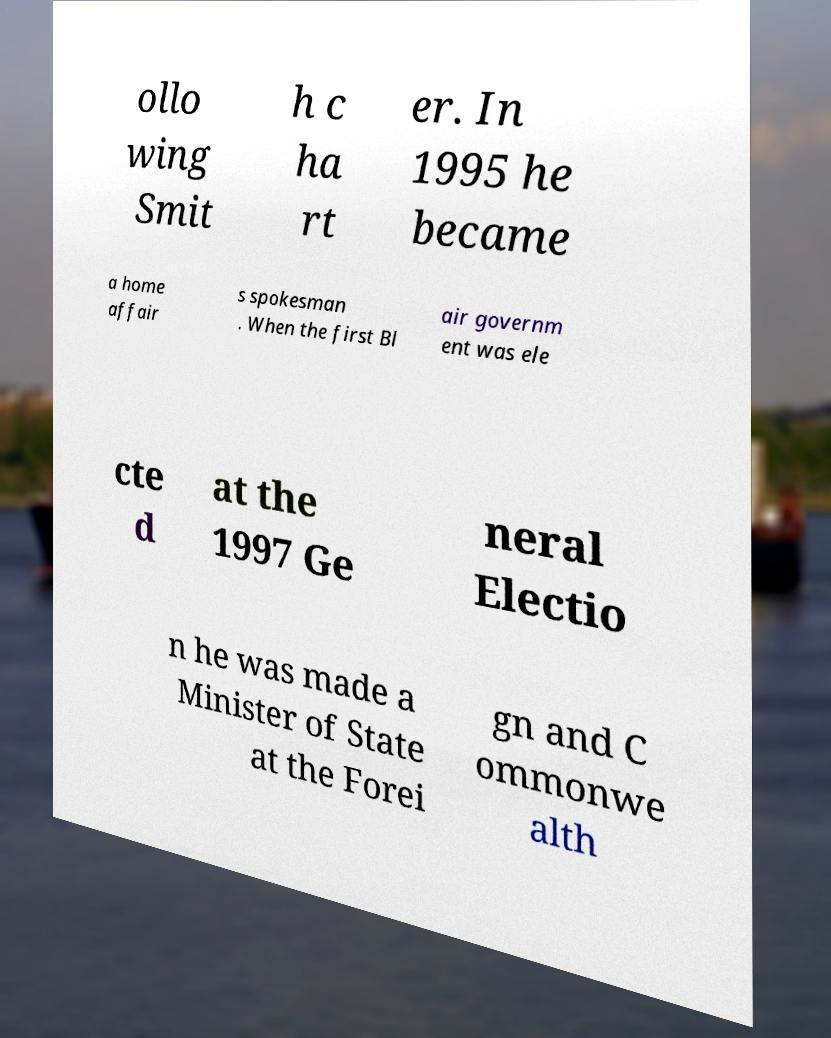Could you extract and type out the text from this image? ollo wing Smit h c ha rt er. In 1995 he became a home affair s spokesman . When the first Bl air governm ent was ele cte d at the 1997 Ge neral Electio n he was made a Minister of State at the Forei gn and C ommonwe alth 